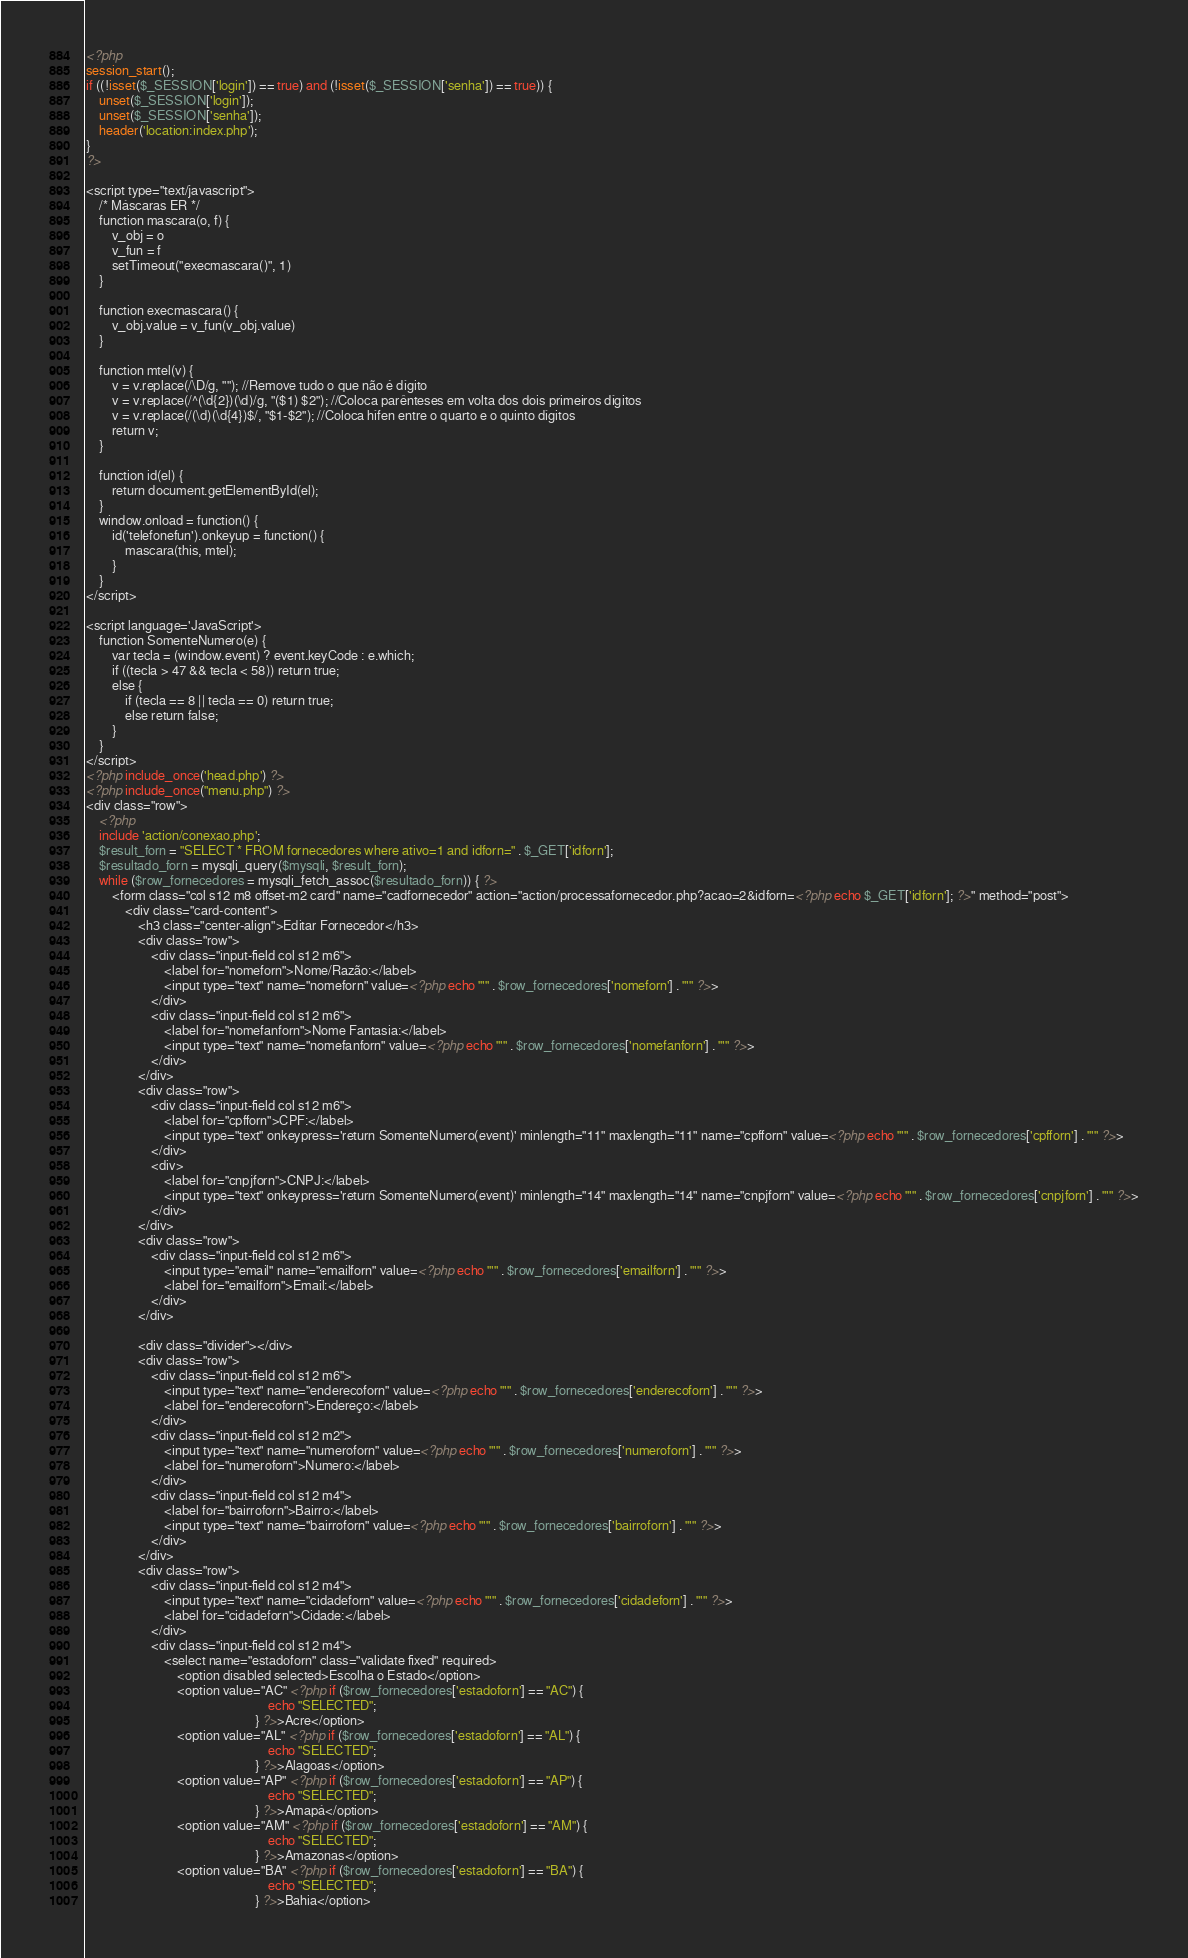<code> <loc_0><loc_0><loc_500><loc_500><_PHP_><?php
session_start();
if ((!isset($_SESSION['login']) == true) and (!isset($_SESSION['senha']) == true)) {
    unset($_SESSION['login']);
    unset($_SESSION['senha']);
    header('location:index.php');
}
?>

<script type="text/javascript">
    /* Máscaras ER */
    function mascara(o, f) {
        v_obj = o
        v_fun = f
        setTimeout("execmascara()", 1)
    }

    function execmascara() {
        v_obj.value = v_fun(v_obj.value)
    }

    function mtel(v) {
        v = v.replace(/\D/g, ""); //Remove tudo o que não é dígito
        v = v.replace(/^(\d{2})(\d)/g, "($1) $2"); //Coloca parênteses em volta dos dois primeiros dígitos
        v = v.replace(/(\d)(\d{4})$/, "$1-$2"); //Coloca hífen entre o quarto e o quinto dígitos
        return v;
    }

    function id(el) {
        return document.getElementById(el);
    }
    window.onload = function() {
        id('telefonefun').onkeyup = function() {
            mascara(this, mtel);
        }
    }
</script>

<script language='JavaScript'>
    function SomenteNumero(e) {
        var tecla = (window.event) ? event.keyCode : e.which;
        if ((tecla > 47 && tecla < 58)) return true;
        else {
            if (tecla == 8 || tecla == 0) return true;
            else return false;
        }
    }
</script>
<?php include_once('head.php') ?>
<?php include_once("menu.php") ?>
<div class="row">
    <?php
    include 'action/conexao.php';
    $result_forn = "SELECT * FROM fornecedores where ativo=1 and idforn=" . $_GET['idforn'];
    $resultado_forn = mysqli_query($mysqli, $result_forn);
    while ($row_fornecedores = mysqli_fetch_assoc($resultado_forn)) { ?>
        <form class="col s12 m8 offset-m2 card" name="cadfornecedor" action="action/processafornecedor.php?acao=2&idforn=<?php echo $_GET['idforn']; ?>" method="post">
            <div class="card-content">
                <h3 class="center-align">Editar Fornecedor</h3>
                <div class="row">
                    <div class="input-field col s12 m6">
                        <label for="nomeforn">Nome/Razão:</label>
                        <input type="text" name="nomeforn" value=<?php echo "'" . $row_fornecedores['nomeforn'] . "'" ?>>
                    </div>
                    <div class="input-field col s12 m6">
                        <label for="nomefanforn">Nome Fantasia:</label>
                        <input type="text" name="nomefanforn" value=<?php echo "'" . $row_fornecedores['nomefanforn'] . "'" ?>>
                    </div>
                </div>
                <div class="row">
                    <div class="input-field col s12 m6">
                        <label for="cpfforn">CPF:</label>
                        <input type="text" onkeypress='return SomenteNumero(event)' minlength="11" maxlength="11" name="cpfforn" value=<?php echo "'" . $row_fornecedores['cpfforn'] . "'" ?>>
                    </div>
                    <div>
                        <label for="cnpjforn">CNPJ:</label>
                        <input type="text" onkeypress='return SomenteNumero(event)' minlength="14" maxlength="14" name="cnpjforn" value=<?php echo "'" . $row_fornecedores['cnpjforn'] . "'" ?>>
                    </div>
                </div>
                <div class="row">
                    <div class="input-field col s12 m6">
                        <input type="email" name="emailforn" value=<?php echo "'" . $row_fornecedores['emailforn'] . "'" ?>>
                        <label for="emailforn">Email:</label>
                    </div>
                </div>

                <div class="divider"></div>
                <div class="row">
                    <div class="input-field col s12 m6">
                        <input type="text" name="enderecoforn" value=<?php echo "'" . $row_fornecedores['enderecoforn'] . "'" ?>>
                        <label for="enderecoforn">Endereço:</label>
                    </div>
                    <div class="input-field col s12 m2">
                        <input type="text" name="numeroforn" value=<?php echo "'" . $row_fornecedores['numeroforn'] . "'" ?>>
                        <label for="numeroforn">Numero:</label>
                    </div>
                    <div class="input-field col s12 m4">
                        <label for="bairroforn">Bairro:</label>
                        <input type="text" name="bairroforn" value=<?php echo "'" . $row_fornecedores['bairroforn'] . "'" ?>>
                    </div>
                </div>
                <div class="row">
                    <div class="input-field col s12 m4">
                        <input type="text" name="cidadeforn" value=<?php echo "'" . $row_fornecedores['cidadeforn'] . "'" ?>>
                        <label for="cidadeforn">Cidade:</label>
                    </div>
                    <div class="input-field col s12 m4">
                        <select name="estadoforn" class="validate fixed" required>
                            <option disabled selected>Escolha o Estado</option>
                            <option value="AC" <?php if ($row_fornecedores['estadoforn'] == "AC") {
                                                        echo "SELECTED";
                                                    } ?>>Acre</option>
                            <option value="AL" <?php if ($row_fornecedores['estadoforn'] == "AL") {
                                                        echo "SELECTED";
                                                    } ?>>Alagoas</option>
                            <option value="AP" <?php if ($row_fornecedores['estadoforn'] == "AP") {
                                                        echo "SELECTED";
                                                    } ?>>Amapá</option>
                            <option value="AM" <?php if ($row_fornecedores['estadoforn'] == "AM") {
                                                        echo "SELECTED";
                                                    } ?>>Amazonas</option>
                            <option value="BA" <?php if ($row_fornecedores['estadoforn'] == "BA") {
                                                        echo "SELECTED";
                                                    } ?>>Bahia</option></code> 